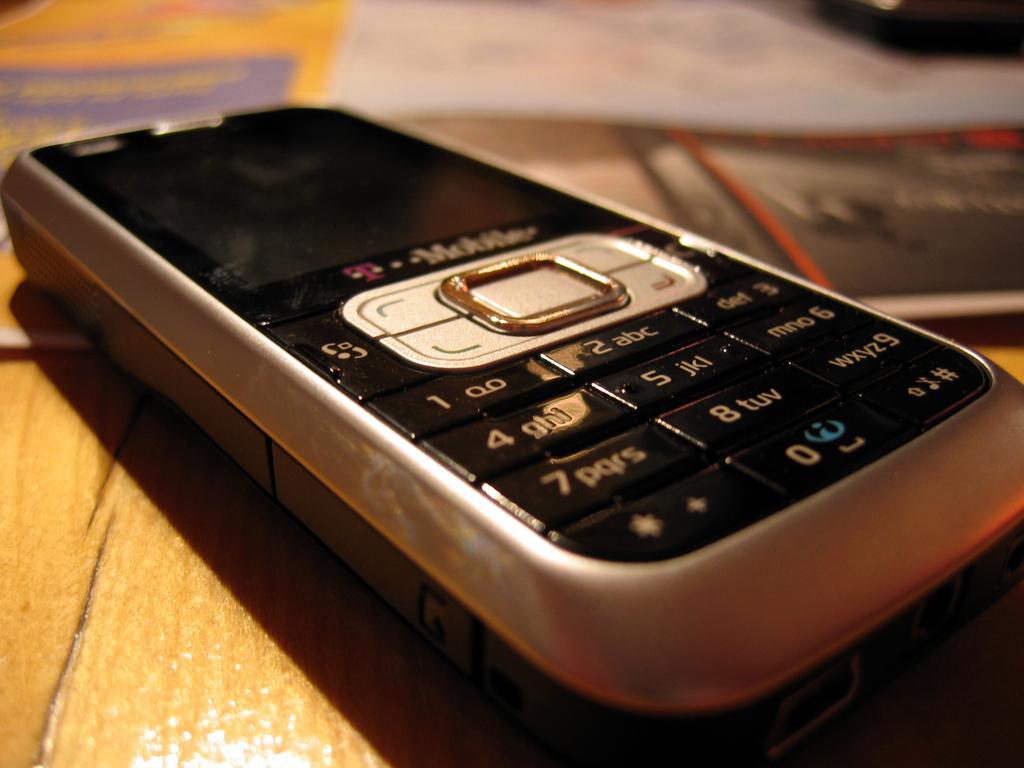Please provide a concise description of this image. In this picture we can see a mobile phone in the front, there is a blurry background, it looks like wooden surface at the bottom. 